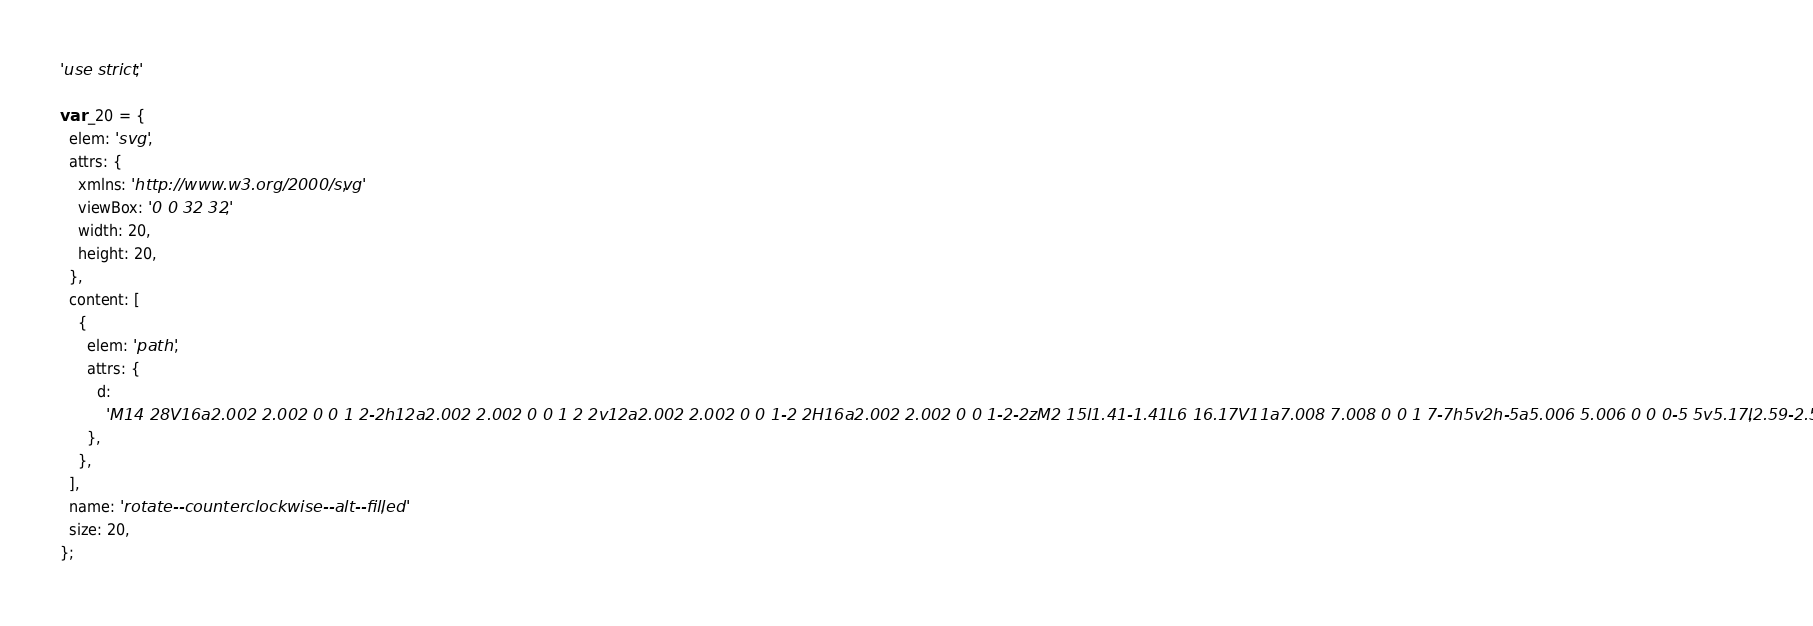<code> <loc_0><loc_0><loc_500><loc_500><_JavaScript_>'use strict';

var _20 = {
  elem: 'svg',
  attrs: {
    xmlns: 'http://www.w3.org/2000/svg',
    viewBox: '0 0 32 32',
    width: 20,
    height: 20,
  },
  content: [
    {
      elem: 'path',
      attrs: {
        d:
          'M14 28V16a2.002 2.002 0 0 1 2-2h12a2.002 2.002 0 0 1 2 2v12a2.002 2.002 0 0 1-2 2H16a2.002 2.002 0 0 1-2-2zM2 15l1.41-1.41L6 16.17V11a7.008 7.008 0 0 1 7-7h5v2h-5a5.006 5.006 0 0 0-5 5v5.17l2.59-2.58L12 15l-5 5z',
      },
    },
  ],
  name: 'rotate--counterclockwise--alt--filled',
  size: 20,
};
</code> 